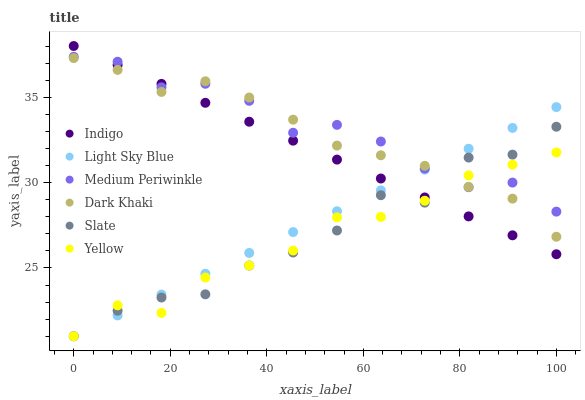Does Yellow have the minimum area under the curve?
Answer yes or no. Yes. Does Medium Periwinkle have the maximum area under the curve?
Answer yes or no. Yes. Does Slate have the minimum area under the curve?
Answer yes or no. No. Does Slate have the maximum area under the curve?
Answer yes or no. No. Is Light Sky Blue the smoothest?
Answer yes or no. Yes. Is Slate the roughest?
Answer yes or no. Yes. Is Medium Periwinkle the smoothest?
Answer yes or no. No. Is Medium Periwinkle the roughest?
Answer yes or no. No. Does Slate have the lowest value?
Answer yes or no. Yes. Does Medium Periwinkle have the lowest value?
Answer yes or no. No. Does Indigo have the highest value?
Answer yes or no. Yes. Does Slate have the highest value?
Answer yes or no. No. Does Indigo intersect Slate?
Answer yes or no. Yes. Is Indigo less than Slate?
Answer yes or no. No. Is Indigo greater than Slate?
Answer yes or no. No. 